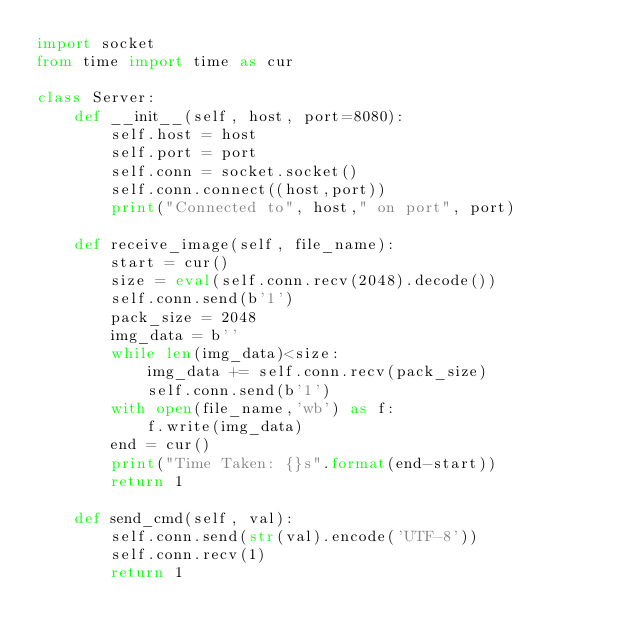Convert code to text. <code><loc_0><loc_0><loc_500><loc_500><_Python_>import socket
from time import time as cur

class Server:
    def __init__(self, host, port=8080):
        self.host = host
        self.port = port
        self.conn = socket.socket()
        self.conn.connect((host,port))
        print("Connected to", host," on port", port) 

    def receive_image(self, file_name):
        start = cur()
        size = eval(self.conn.recv(2048).decode())
        self.conn.send(b'1')
        pack_size = 2048
        img_data = b''
        while len(img_data)<size:
            img_data += self.conn.recv(pack_size)
            self.conn.send(b'1')
        with open(file_name,'wb') as f:
            f.write(img_data)
        end = cur()
        print("Time Taken: {}s".format(end-start))
        return 1

    def send_cmd(self, val):
        self.conn.send(str(val).encode('UTF-8'))
        self.conn.recv(1)
        return 1
</code> 